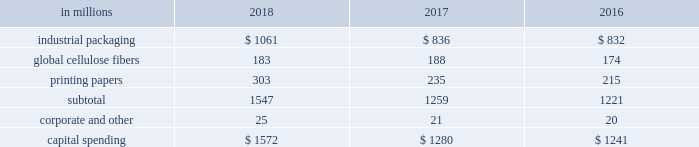The company recorded equity earnings , net of taxes , related to ilim of $ 290 million in 2018 , compared with earnings of $ 183 million in 2017 , and $ 199 million in 2016 .
Operating results recorded in 2018 included an after-tax non-cash foreign exchange loss of $ 82 million , compared with an after-tax foreign exchange gain of $ 15 million in 2017 and an after-tax foreign exchange gain of $ 25 million in 2016 , primarily on the remeasurement of ilim's u.s .
Dollar denominated net debt .
Ilim delivered outstanding performance in 2018 , driven largely by higher price realization and strong demand .
Sales volumes for the joint venture increased year over year for shipments to china of softwood pulp and linerboard , but were offset by decreased sales of hardwood pulp to china .
Sales volumes in the russian market increased for softwood pulp and hardwood pulp , but decreased for linerboard .
Average sales price realizations were significantly higher in 2018 for sales of softwood pulp , hardwood pulp and linerboard to china and other export markets .
Average sales price realizations in russian markets increased year over year for all products .
Input costs were higher in 2018 , primarily for wood , fuel and chemicals .
Distribution costs were negatively impacted by tariffs and inflation .
The company received cash dividends from the joint venture of $ 128 million in 2018 , $ 133 million in 2017 and $ 58 million in entering the first quarter of 2019 , sales volumes are expected to be lower than in the fourth quarter of 2018 , due to the seasonal slowdown in china and fewer trading days .
Based on pricing to date in the current quarter , average sales prices are expected to decrease for hardwood pulp , softwood pulp and linerboard to china .
Input costs are projected to be relatively flat , while distribution costs are expected to increase .
Equity earnings - gpip international paper recorded equity earnings of $ 46 million on its 20.5% ( 20.5 % ) ownership position in gpip in 2018 .
The company received cash dividends from the investment of $ 25 million in 2018 .
Liquidity and capital resources overview a major factor in international paper 2019s liquidity and capital resource planning is its generation of operating cash flow , which is highly sensitive to changes in the pricing and demand for our major products .
While changes in key cash operating costs , such as energy , raw material , mill outage and transportation costs , do have an effect on operating cash generation , we believe that our focus on pricing and cost controls has improved our cash flow generation over an operating cycle .
Cash uses during 2018 were primarily focused on working capital requirements , capital spending , debt reductions and returning cash to shareholders through dividends and share repurchases under the company's share repurchase program .
Cash provided by operating activities cash provided by operations , including discontinued operations , totaled $ 3.2 billion in 2018 , compared with $ 1.8 billion for 2017 , and $ 2.5 billion for 2016 .
Cash used by working capital components ( accounts receivable , contract assets and inventory less accounts payable and accrued liabilities , interest payable and other ) totaled $ 439 million in 2018 , compared with cash used by working capital components of $ 402 million in 2017 , and cash provided by working capital components of $ 71 million in 2016 .
Investment activities including discontinued operations , investment activities in 2018 increased from 2017 , as 2018 included higher capital spending .
In 2016 , investment activity included the purchase of weyerhaeuser's pulp business for $ 2.2 billion in cash , the purchase of the holmen business for $ 57 million in cash , net of cash acquired , and proceeds from the sale of the asia packaging business of $ 108 million , net of cash divested .
The company maintains an average capital spending target around depreciation and amortization levels , or modestly above , due to strategic plans over the course of an economic cycle .
Capital spending was $ 1.6 billion in 2018 , or 118% ( 118 % ) of depreciation and amortization , compared with $ 1.4 billion in 2017 , or 98% ( 98 % ) of depreciation and amortization , and $ 1.3 billion , or 110% ( 110 % ) of depreciation and amortization in 2016 .
Across our segments , capital spending as a percentage of depreciation and amortization ranged from 69.8% ( 69.8 % ) to 132.1% ( 132.1 % ) in 2018 .
The table shows capital spending for operations by business segment for the years ended december 31 , 2018 , 2017 and 2016 , excluding amounts related to discontinued operations of $ 111 million in 2017 and $ 107 million in 2016. .
Capital expenditures in 2019 are currently expected to be about $ 1.4 billion , or 104% ( 104 % ) of depreciation and amortization , including approximately $ 400 million of strategic investments. .
What was the percentage increase of capital expenditures for operations in the industrial packaging business segment in from 2017 to 2018? 
Computations: ((1061 - 836) / 836)
Answer: 0.26914. The company recorded equity earnings , net of taxes , related to ilim of $ 290 million in 2018 , compared with earnings of $ 183 million in 2017 , and $ 199 million in 2016 .
Operating results recorded in 2018 included an after-tax non-cash foreign exchange loss of $ 82 million , compared with an after-tax foreign exchange gain of $ 15 million in 2017 and an after-tax foreign exchange gain of $ 25 million in 2016 , primarily on the remeasurement of ilim's u.s .
Dollar denominated net debt .
Ilim delivered outstanding performance in 2018 , driven largely by higher price realization and strong demand .
Sales volumes for the joint venture increased year over year for shipments to china of softwood pulp and linerboard , but were offset by decreased sales of hardwood pulp to china .
Sales volumes in the russian market increased for softwood pulp and hardwood pulp , but decreased for linerboard .
Average sales price realizations were significantly higher in 2018 for sales of softwood pulp , hardwood pulp and linerboard to china and other export markets .
Average sales price realizations in russian markets increased year over year for all products .
Input costs were higher in 2018 , primarily for wood , fuel and chemicals .
Distribution costs were negatively impacted by tariffs and inflation .
The company received cash dividends from the joint venture of $ 128 million in 2018 , $ 133 million in 2017 and $ 58 million in entering the first quarter of 2019 , sales volumes are expected to be lower than in the fourth quarter of 2018 , due to the seasonal slowdown in china and fewer trading days .
Based on pricing to date in the current quarter , average sales prices are expected to decrease for hardwood pulp , softwood pulp and linerboard to china .
Input costs are projected to be relatively flat , while distribution costs are expected to increase .
Equity earnings - gpip international paper recorded equity earnings of $ 46 million on its 20.5% ( 20.5 % ) ownership position in gpip in 2018 .
The company received cash dividends from the investment of $ 25 million in 2018 .
Liquidity and capital resources overview a major factor in international paper 2019s liquidity and capital resource planning is its generation of operating cash flow , which is highly sensitive to changes in the pricing and demand for our major products .
While changes in key cash operating costs , such as energy , raw material , mill outage and transportation costs , do have an effect on operating cash generation , we believe that our focus on pricing and cost controls has improved our cash flow generation over an operating cycle .
Cash uses during 2018 were primarily focused on working capital requirements , capital spending , debt reductions and returning cash to shareholders through dividends and share repurchases under the company's share repurchase program .
Cash provided by operating activities cash provided by operations , including discontinued operations , totaled $ 3.2 billion in 2018 , compared with $ 1.8 billion for 2017 , and $ 2.5 billion for 2016 .
Cash used by working capital components ( accounts receivable , contract assets and inventory less accounts payable and accrued liabilities , interest payable and other ) totaled $ 439 million in 2018 , compared with cash used by working capital components of $ 402 million in 2017 , and cash provided by working capital components of $ 71 million in 2016 .
Investment activities including discontinued operations , investment activities in 2018 increased from 2017 , as 2018 included higher capital spending .
In 2016 , investment activity included the purchase of weyerhaeuser's pulp business for $ 2.2 billion in cash , the purchase of the holmen business for $ 57 million in cash , net of cash acquired , and proceeds from the sale of the asia packaging business of $ 108 million , net of cash divested .
The company maintains an average capital spending target around depreciation and amortization levels , or modestly above , due to strategic plans over the course of an economic cycle .
Capital spending was $ 1.6 billion in 2018 , or 118% ( 118 % ) of depreciation and amortization , compared with $ 1.4 billion in 2017 , or 98% ( 98 % ) of depreciation and amortization , and $ 1.3 billion , or 110% ( 110 % ) of depreciation and amortization in 2016 .
Across our segments , capital spending as a percentage of depreciation and amortization ranged from 69.8% ( 69.8 % ) to 132.1% ( 132.1 % ) in 2018 .
The table shows capital spending for operations by business segment for the years ended december 31 , 2018 , 2017 and 2016 , excluding amounts related to discontinued operations of $ 111 million in 2017 and $ 107 million in 2016. .
Capital expenditures in 2019 are currently expected to be about $ 1.4 billion , or 104% ( 104 % ) of depreciation and amortization , including approximately $ 400 million of strategic investments. .
What was the percentage of capital expenditures for operations in the industrial packaging business segment in 2018? 
Computations: (1061 / 1572)
Answer: 0.67494. 